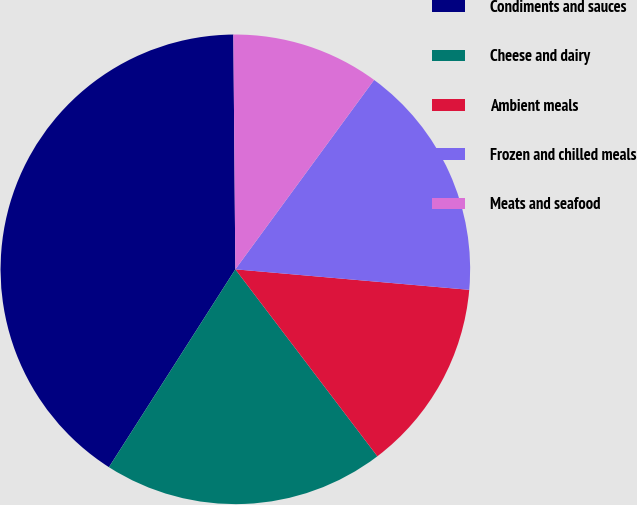<chart> <loc_0><loc_0><loc_500><loc_500><pie_chart><fcel>Condiments and sauces<fcel>Cheese and dairy<fcel>Ambient meals<fcel>Frozen and chilled meals<fcel>Meats and seafood<nl><fcel>40.82%<fcel>19.39%<fcel>13.27%<fcel>16.33%<fcel>10.2%<nl></chart> 